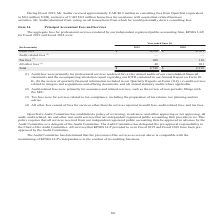According to Opentext Corporation's financial document, What company renders the professional service to Open Text Corporation According to the financial document, KPMG LLP. The relevant text states: "ur independent registered public accounting firm, KPMG LLP, for Fiscal 2019 and Fiscal 2018 were:..." Also, What years did KPMG LLP provide service to the company that was preapproved by the Audit Committee? Fiscal 2019 and Fiscal 2018. The document states: "registered public accounting firm, KPMG LLP, for Fiscal 2019 and Fiscal 2018 were:..." Also, What units does the table use? According to the financial document, thousands. The relevant text states: "(In thousands) 2019 2018 Audit fees (1) $ 4,598 $ 4,701 Audit-related fees (2) — — Tax fees (3) 108 116 All other..." Also, can you calculate: In year ended 2019, what is the Audit fees expressed as a percentage of total fees? Based on the calculation: 4,598/4,746, the result is 96.88 (percentage). This is based on the information: "ees (3) 108 116 All other fees (4) 40 101 Total $ 4,746 $ 4,918 (In thousands) 2019 2018 Audit fees (1) $ 4,598 $ 4,701 Audit-related fees (2) — — Tax fees (3) 108 116 All other fees (4) 40 101 Total ..." The key data points involved are: 4,598, 4,746. Also, can you calculate: What is the average annual total Fees for Fiscal year 2019 and 2018? To answer this question, I need to perform calculations using the financial data. The calculation is: (4,746+4,918)/2, which equals 4832 (in thousands). This is based on the information: "ees (3) 108 116 All other fees (4) 40 101 Total $ 4,746 $ 4,918 108 116 All other fees (4) 40 101 Total $ 4,746 $ 4,918..." The key data points involved are: 4,746, 4,918. Also, can you calculate: What is the Tax fees for fiscal year 2019 expressed as a percentage of total fees? Based on the calculation: 108/4,746, the result is 2.28 (percentage). This is based on the information: "ees (3) 108 116 All other fees (4) 40 101 Total $ 4,746 $ 4,918 8 $ 4,701 Audit-related fees (2) — — Tax fees (3) 108 116 All other fees (4) 40 101 Total $ 4,746 $ 4,918..." The key data points involved are: 108, 4,746. 